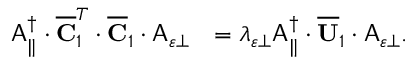Convert formula to latex. <formula><loc_0><loc_0><loc_500><loc_500>\begin{array} { r l } { A _ { \| } ^ { \dagger } \cdot \overline { C } _ { 1 } ^ { T } \cdot \overline { C } _ { 1 } \cdot A _ { \varepsilon \perp } } & { = \lambda _ { \varepsilon \perp } A _ { \| } ^ { \dagger } \cdot \overline { U } _ { 1 } \cdot A _ { \varepsilon \perp } . } \end{array}</formula> 